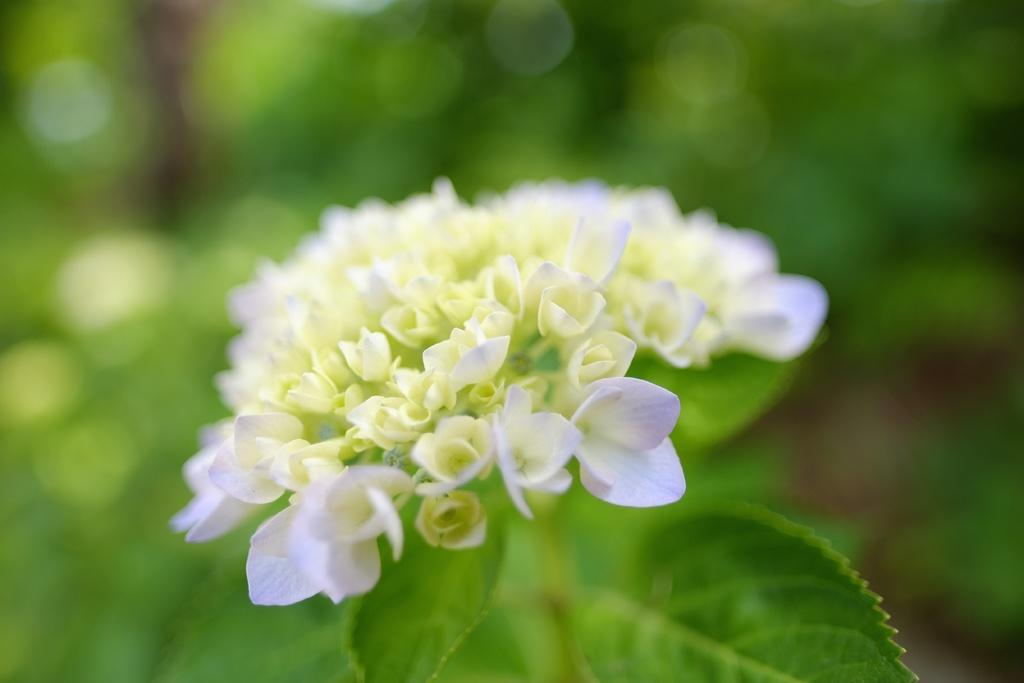What type of living organisms can be seen in the image? Plants and flowers are visible in the image. Can you describe the group of flowers in the image? There is a group of flowers in the image, and they are white in color. What type of card can be seen in the image? There is no card present in the image. How does the disease affect the plants in the image? There is no indication of any disease affecting the plants in the image. 